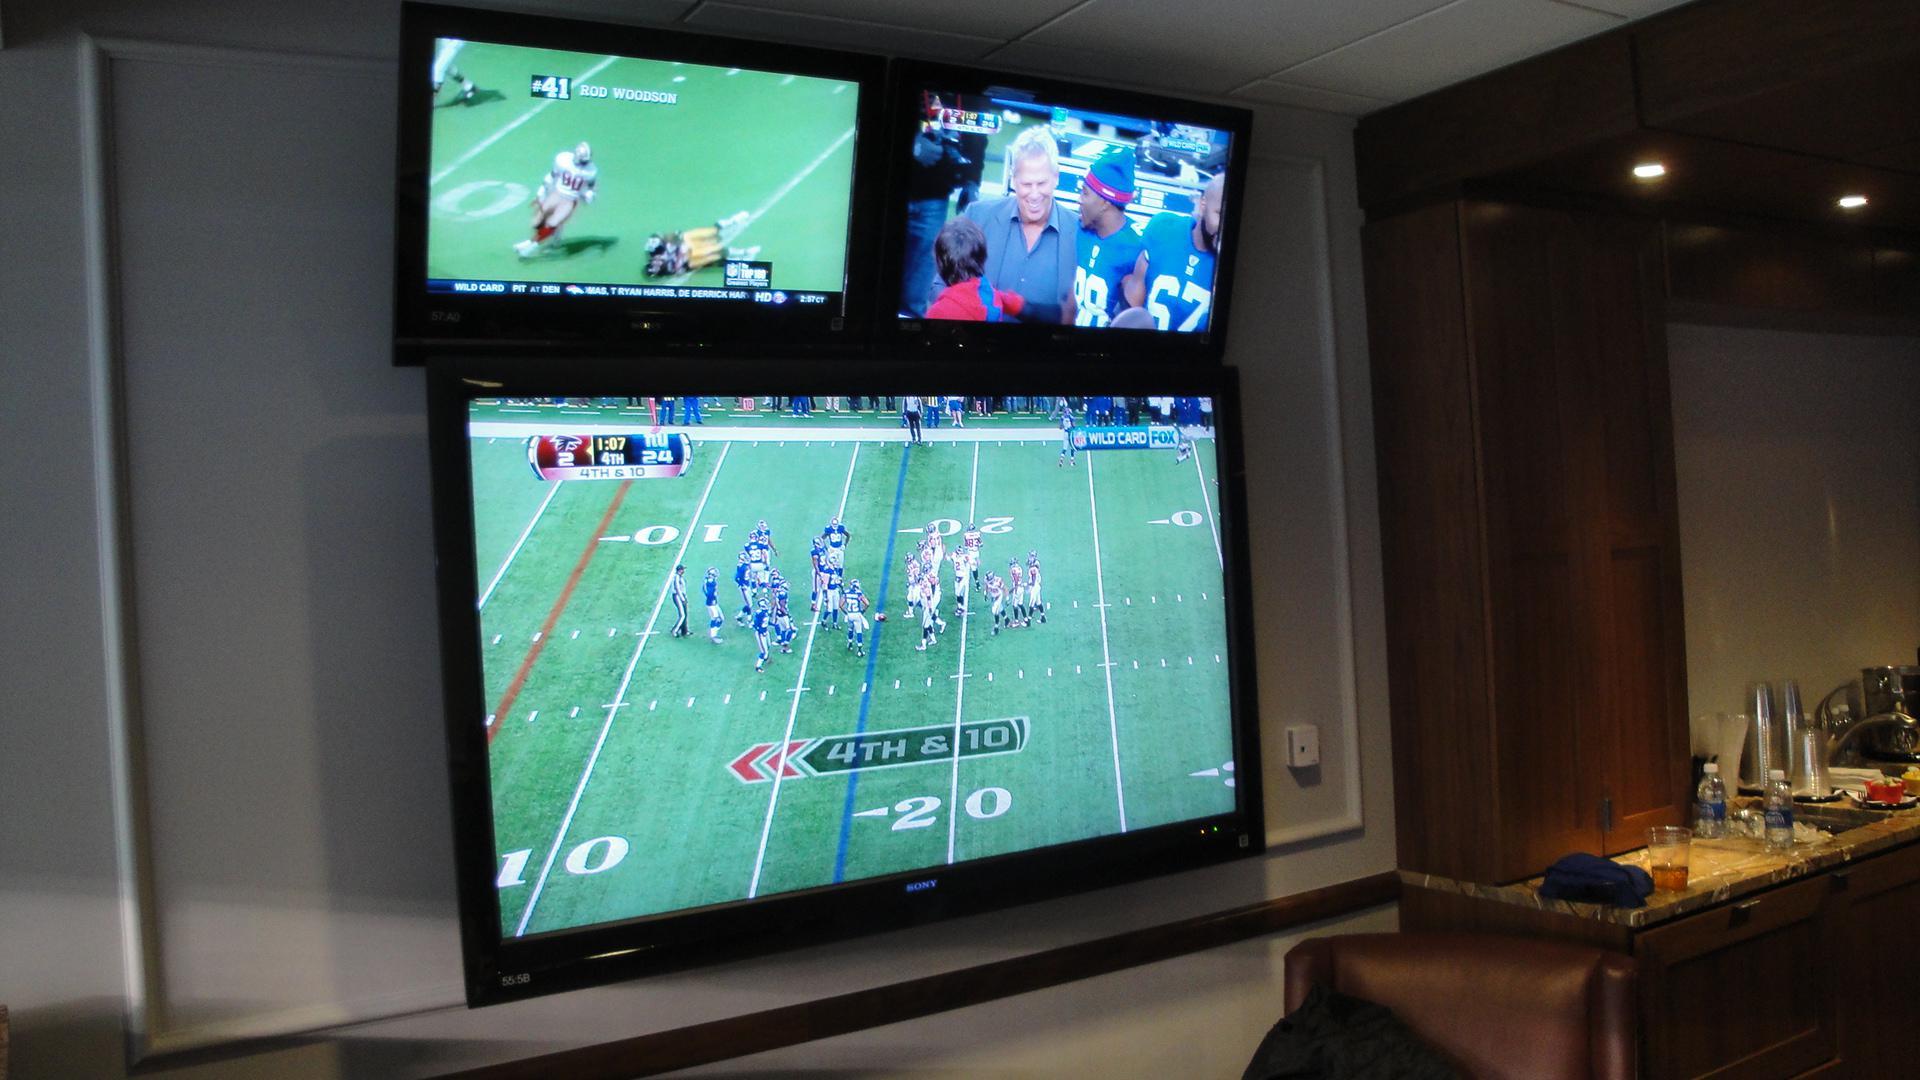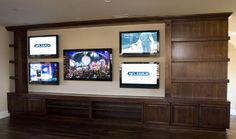The first image is the image on the left, the second image is the image on the right. Examine the images to the left and right. Is the description "The right image shows a symmetrical grouping of at least four screens mounted on an inset wall surrounded by brown wood." accurate? Answer yes or no. Yes. The first image is the image on the left, the second image is the image on the right. For the images displayed, is the sentence "Cushioned furniture is positioned near screens mounted on the wall in one of the images." factually correct? Answer yes or no. No. 